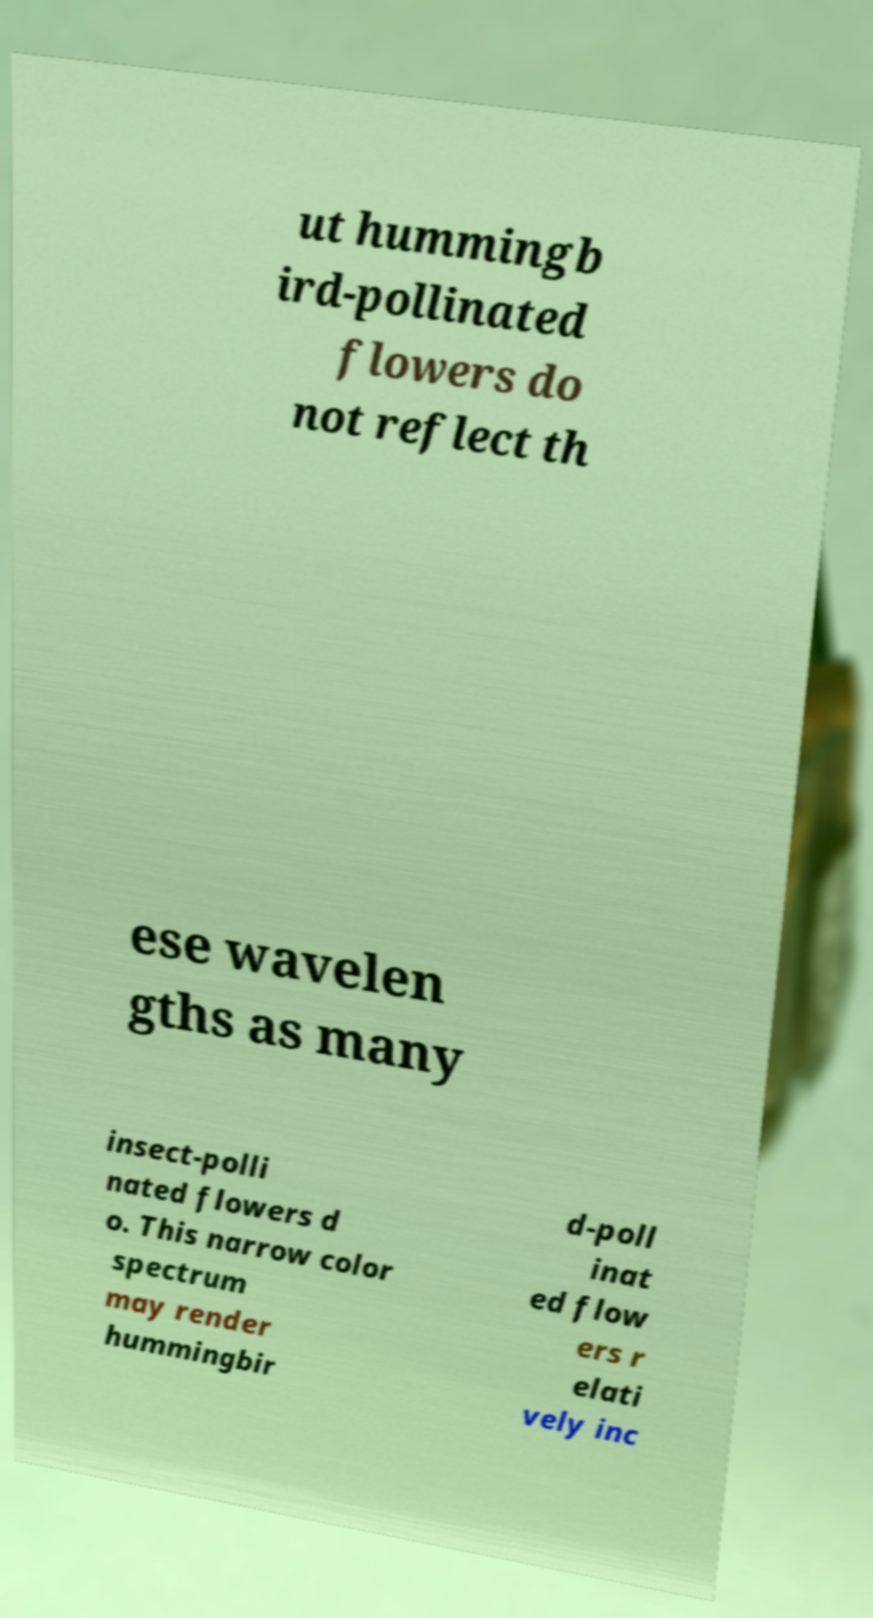Could you extract and type out the text from this image? ut hummingb ird-pollinated flowers do not reflect th ese wavelen gths as many insect-polli nated flowers d o. This narrow color spectrum may render hummingbir d-poll inat ed flow ers r elati vely inc 